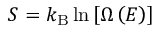Convert formula to latex. <formula><loc_0><loc_0><loc_500><loc_500>S = k _ { B } \ln \left [ \Omega \left ( E \right ) \right ]</formula> 